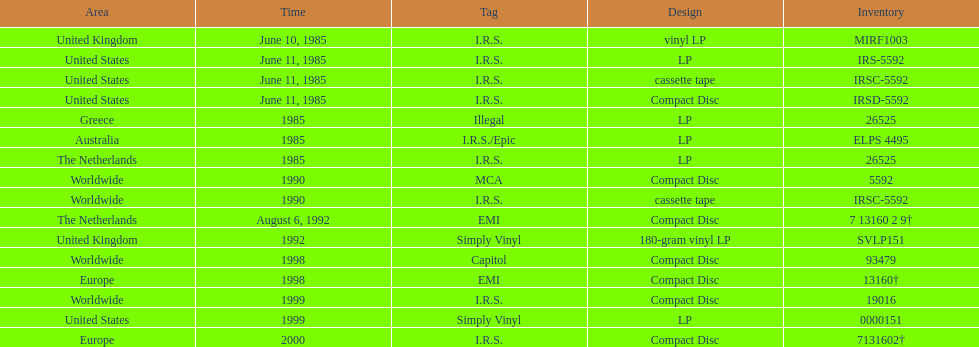Which year had the most releases? 1985. 